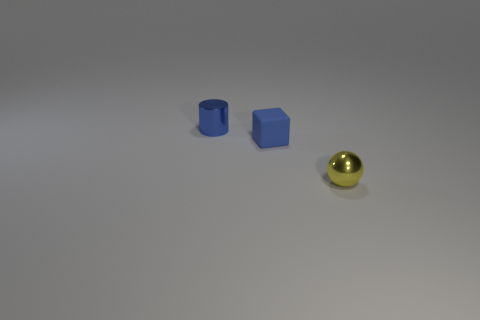Do the blue thing that is in front of the tiny metallic cylinder and the small object in front of the blue block have the same material?
Your response must be concise. No. The metallic object in front of the small blue metallic cylinder has what shape?
Provide a short and direct response. Sphere. Is the number of blue cylinders less than the number of blue balls?
Make the answer very short. No. There is a small blue object in front of the small cylinder left of the blue matte thing; are there any tiny balls left of it?
Give a very brief answer. No. How many rubber things are gray balls or yellow things?
Keep it short and to the point. 0. Do the tiny rubber thing and the cylinder have the same color?
Make the answer very short. Yes. What number of small blue cubes are in front of the blue rubber object?
Offer a terse response. 0. How many things are both to the left of the blue rubber block and in front of the tiny cylinder?
Ensure brevity in your answer.  0. The yellow thing that is made of the same material as the blue cylinder is what shape?
Offer a very short reply. Sphere. There is a small metallic object on the left side of the tiny metal sphere; what color is it?
Offer a very short reply. Blue. 